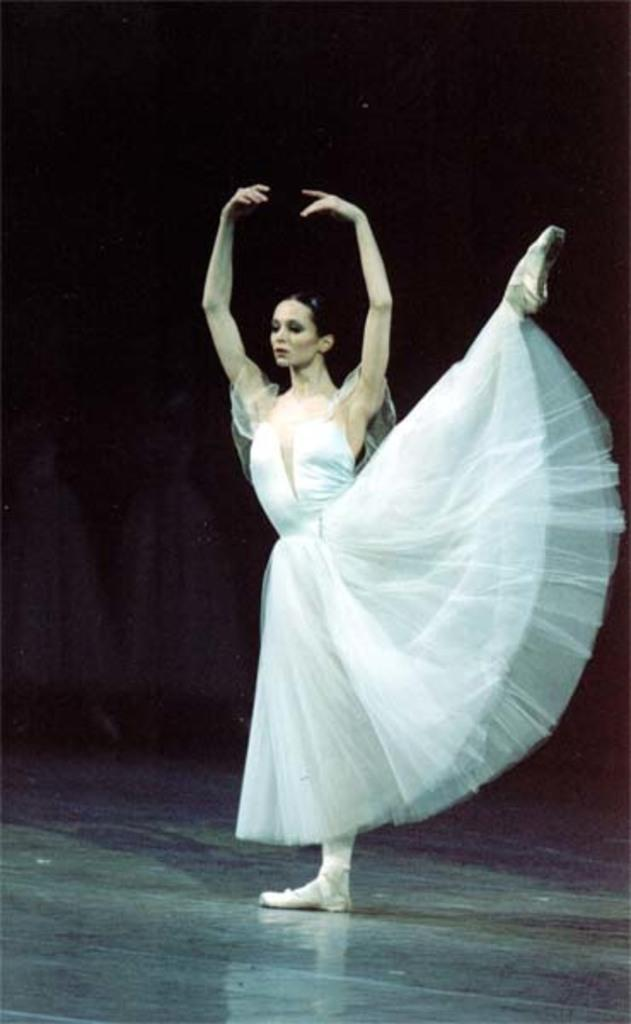Who is the main subject in the image? There is a woman in the image. What is the woman doing in the image? The woman is in a dancing pose. Where is the woman located in the image? The woman is on a stage. What is the purpose of the woman's tail in the image? There is no tail present on the woman in the image. 